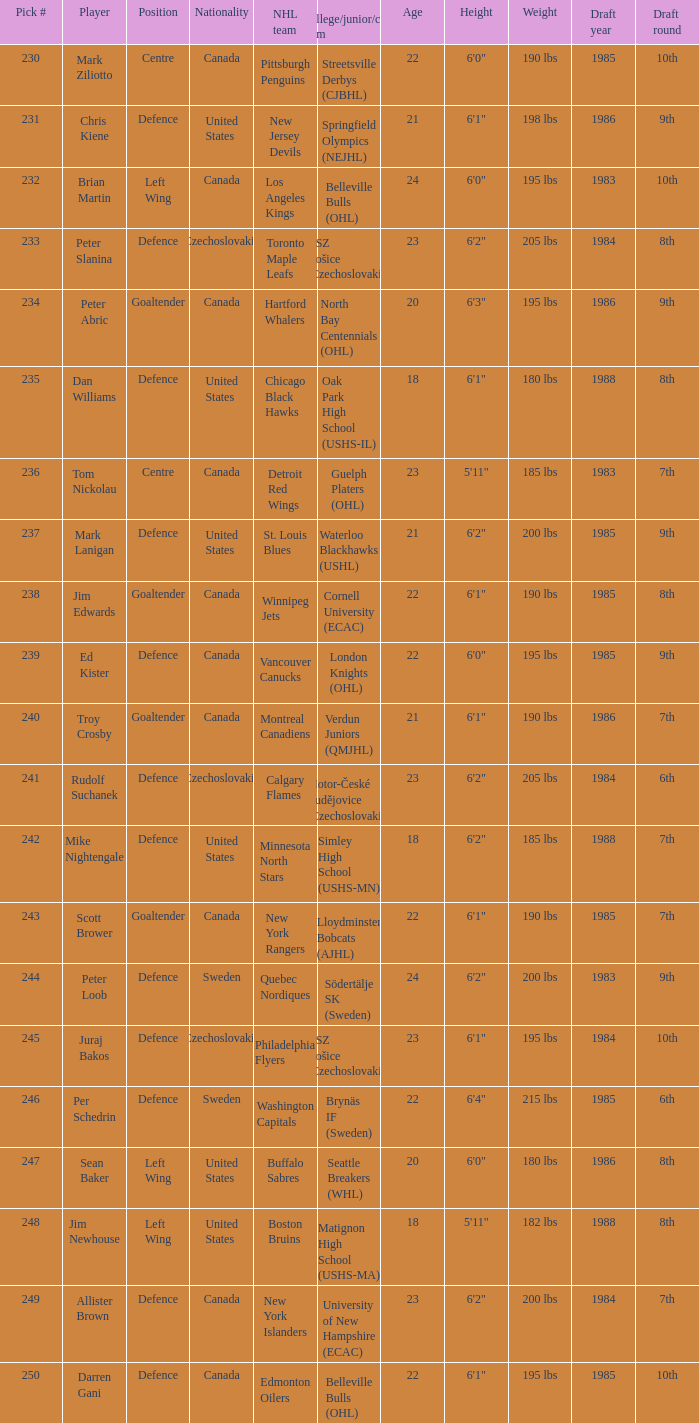Which draft number did the new jersey devils get? 231.0. 